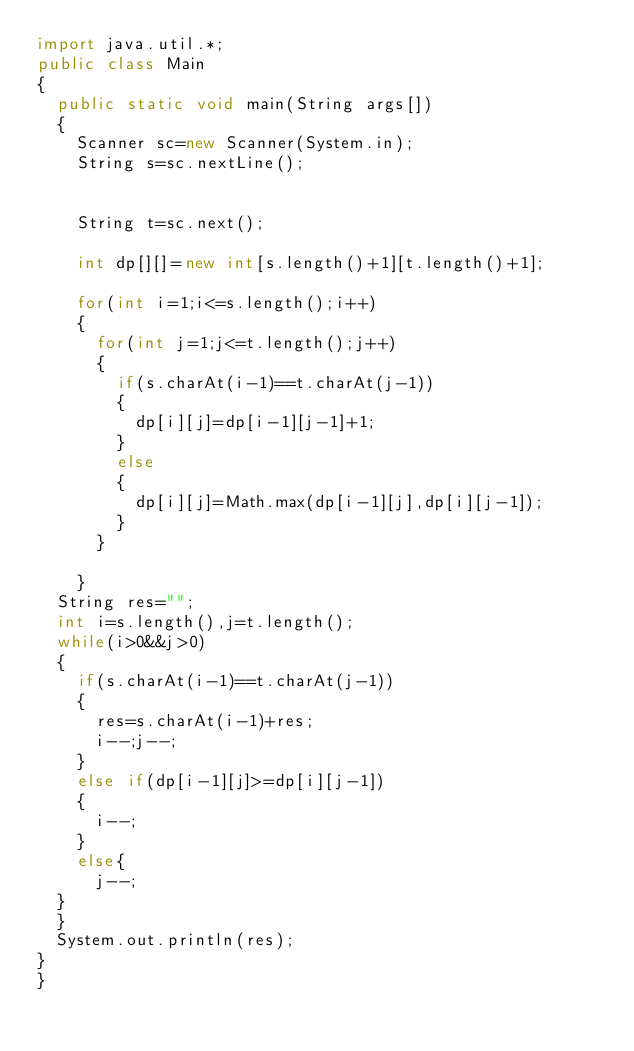Convert code to text. <code><loc_0><loc_0><loc_500><loc_500><_Java_>import java.util.*;
public class Main
{
  public static void main(String args[])
  {
	  Scanner sc=new Scanner(System.in);
    String s=sc.nextLine();
   
    
    String t=sc.next();
	
    int dp[][]=new int[s.length()+1][t.length()+1];
   
    for(int i=1;i<=s.length();i++)
    {
      for(int j=1;j<=t.length();j++)
      {
        if(s.charAt(i-1)==t.charAt(j-1))
        {
          dp[i][j]=dp[i-1][j-1]+1;
        }
        else
        {
          dp[i][j]=Math.max(dp[i-1][j],dp[i][j-1]);
        }
      }
      
    }
	String res="";
	int i=s.length(),j=t.length();
	while(i>0&&j>0)
	{
		if(s.charAt(i-1)==t.charAt(j-1))
		{
			res=s.charAt(i-1)+res;
			i--;j--;
		}
		else if(dp[i-1][j]>=dp[i][j-1])
		{
			i--;
		}
		else{
			j--;
	}  
	}
	System.out.println(res);
}
}</code> 